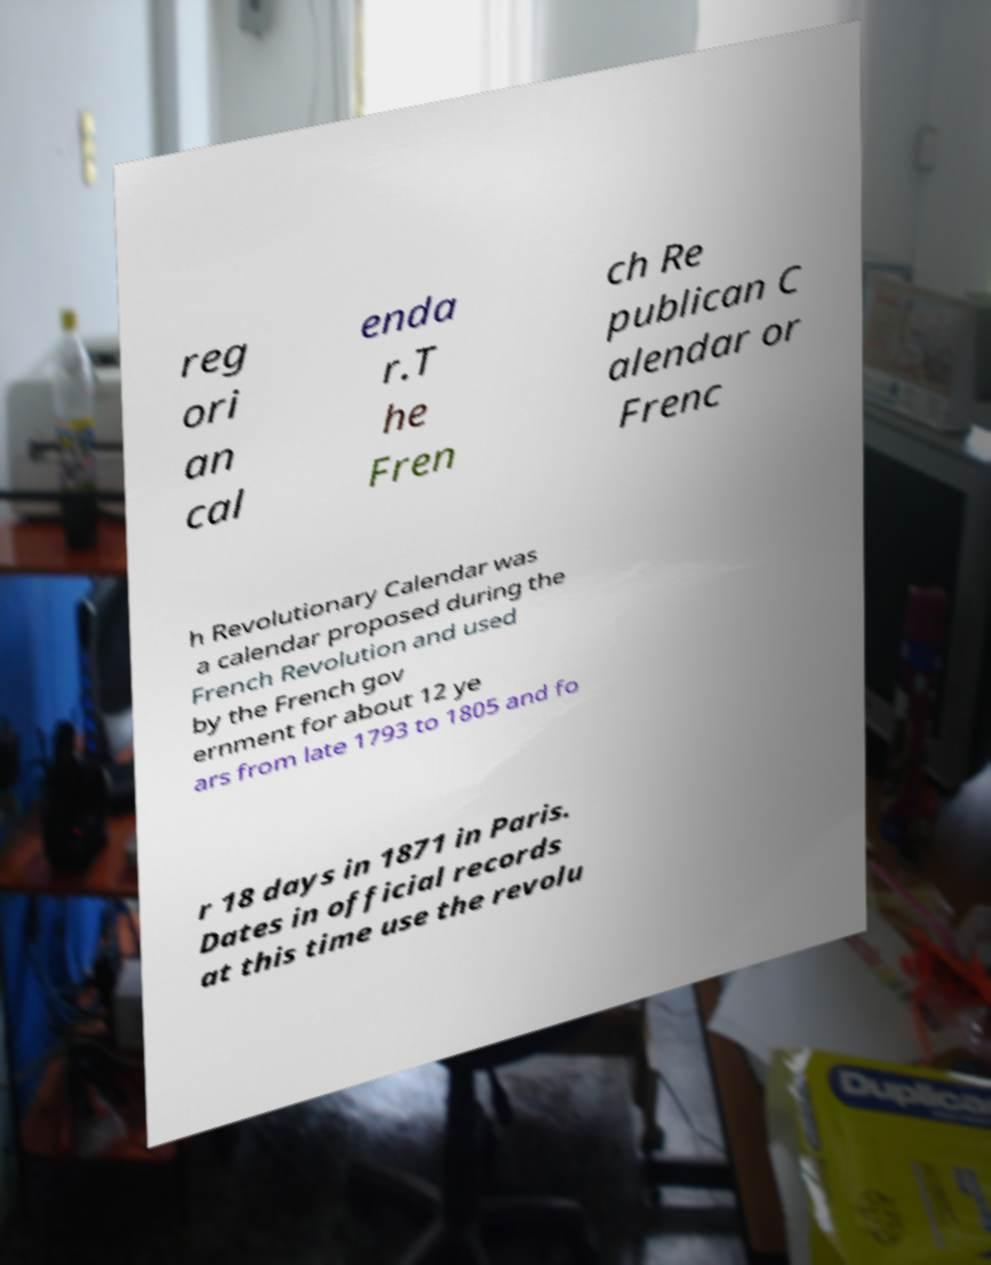There's text embedded in this image that I need extracted. Can you transcribe it verbatim? reg ori an cal enda r.T he Fren ch Re publican C alendar or Frenc h Revolutionary Calendar was a calendar proposed during the French Revolution and used by the French gov ernment for about 12 ye ars from late 1793 to 1805 and fo r 18 days in 1871 in Paris. Dates in official records at this time use the revolu 